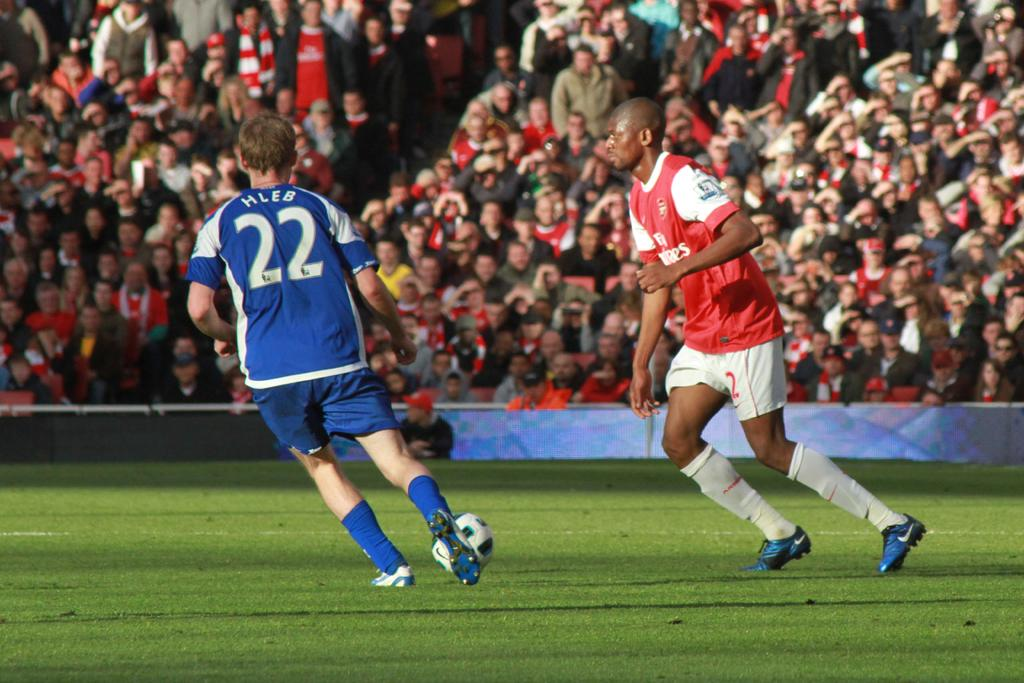<image>
Write a terse but informative summary of the picture. A soccer player wearing number 22 is named Hleb. 